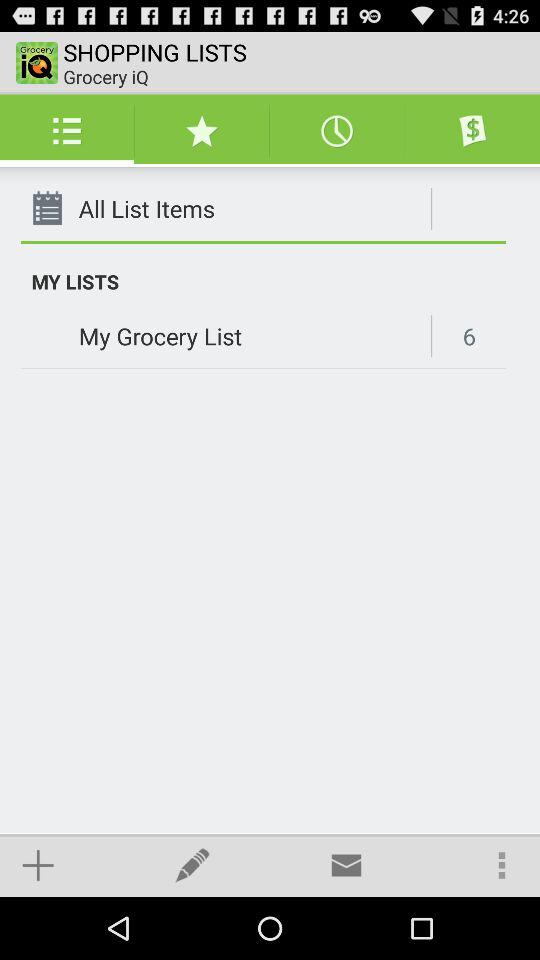How many items are on my grocery list? There are 6 items. 